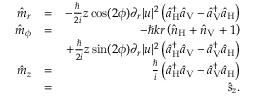<formula> <loc_0><loc_0><loc_500><loc_500>\begin{array} { r l r } { \hat { m } _ { r } } & { = } & { - \frac { } { 2 i } z \cos ( 2 \phi ) \partial _ { r } | u | ^ { 2 } \left ( \hat { a } _ { H } ^ { \dagger } \hat { a } _ { V } - \hat { a } _ { V } ^ { \dagger } \hat { a } _ { H } \right ) } \\ { \hat { m } _ { \phi } } & { = } & { - \hbar { k } r \left ( \hat { n } _ { H } + \hat { n } _ { V } + 1 \right ) } \\ & { + \frac { } { 2 i } z \sin ( 2 \phi ) \partial _ { r } | u | ^ { 2 } \left ( \hat { a } _ { H } ^ { \dagger } \hat { a } _ { V } - \hat { a } _ { V } ^ { \dagger } \hat { a } _ { H } \right ) } \\ { \hat { m } _ { z } } & { = } & { \frac { } { i } \left ( \hat { a } _ { H } ^ { \dagger } \hat { a } _ { V } - \hat { a } _ { V } ^ { \dagger } \hat { a } _ { H } \right ) } \\ & { = } & { \hat { s } _ { z } . } \end{array}</formula> 